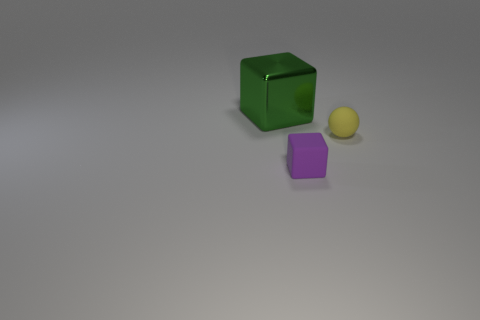Subtract all spheres. How many objects are left? 2 Subtract 1 spheres. How many spheres are left? 0 Subtract all yellow cylinders. How many green blocks are left? 1 Subtract all large green metal objects. Subtract all large objects. How many objects are left? 1 Add 1 big green objects. How many big green objects are left? 2 Add 3 cyan blocks. How many cyan blocks exist? 3 Add 1 big green rubber blocks. How many objects exist? 4 Subtract 0 green cylinders. How many objects are left? 3 Subtract all brown spheres. Subtract all green cylinders. How many spheres are left? 1 